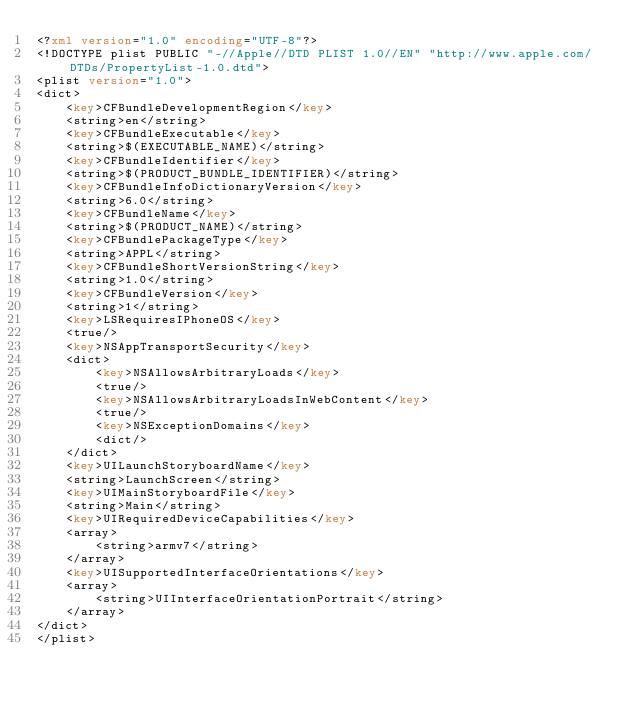Convert code to text. <code><loc_0><loc_0><loc_500><loc_500><_XML_><?xml version="1.0" encoding="UTF-8"?>
<!DOCTYPE plist PUBLIC "-//Apple//DTD PLIST 1.0//EN" "http://www.apple.com/DTDs/PropertyList-1.0.dtd">
<plist version="1.0">
<dict>
	<key>CFBundleDevelopmentRegion</key>
	<string>en</string>
	<key>CFBundleExecutable</key>
	<string>$(EXECUTABLE_NAME)</string>
	<key>CFBundleIdentifier</key>
	<string>$(PRODUCT_BUNDLE_IDENTIFIER)</string>
	<key>CFBundleInfoDictionaryVersion</key>
	<string>6.0</string>
	<key>CFBundleName</key>
	<string>$(PRODUCT_NAME)</string>
	<key>CFBundlePackageType</key>
	<string>APPL</string>
	<key>CFBundleShortVersionString</key>
	<string>1.0</string>
	<key>CFBundleVersion</key>
	<string>1</string>
	<key>LSRequiresIPhoneOS</key>
	<true/>
	<key>NSAppTransportSecurity</key>
	<dict>
		<key>NSAllowsArbitraryLoads</key>
		<true/>
		<key>NSAllowsArbitraryLoadsInWebContent</key>
		<true/>
		<key>NSExceptionDomains</key>
		<dict/>
	</dict>
	<key>UILaunchStoryboardName</key>
	<string>LaunchScreen</string>
	<key>UIMainStoryboardFile</key>
	<string>Main</string>
	<key>UIRequiredDeviceCapabilities</key>
	<array>
		<string>armv7</string>
	</array>
	<key>UISupportedInterfaceOrientations</key>
	<array>
		<string>UIInterfaceOrientationPortrait</string>
	</array>
</dict>
</plist>
</code> 